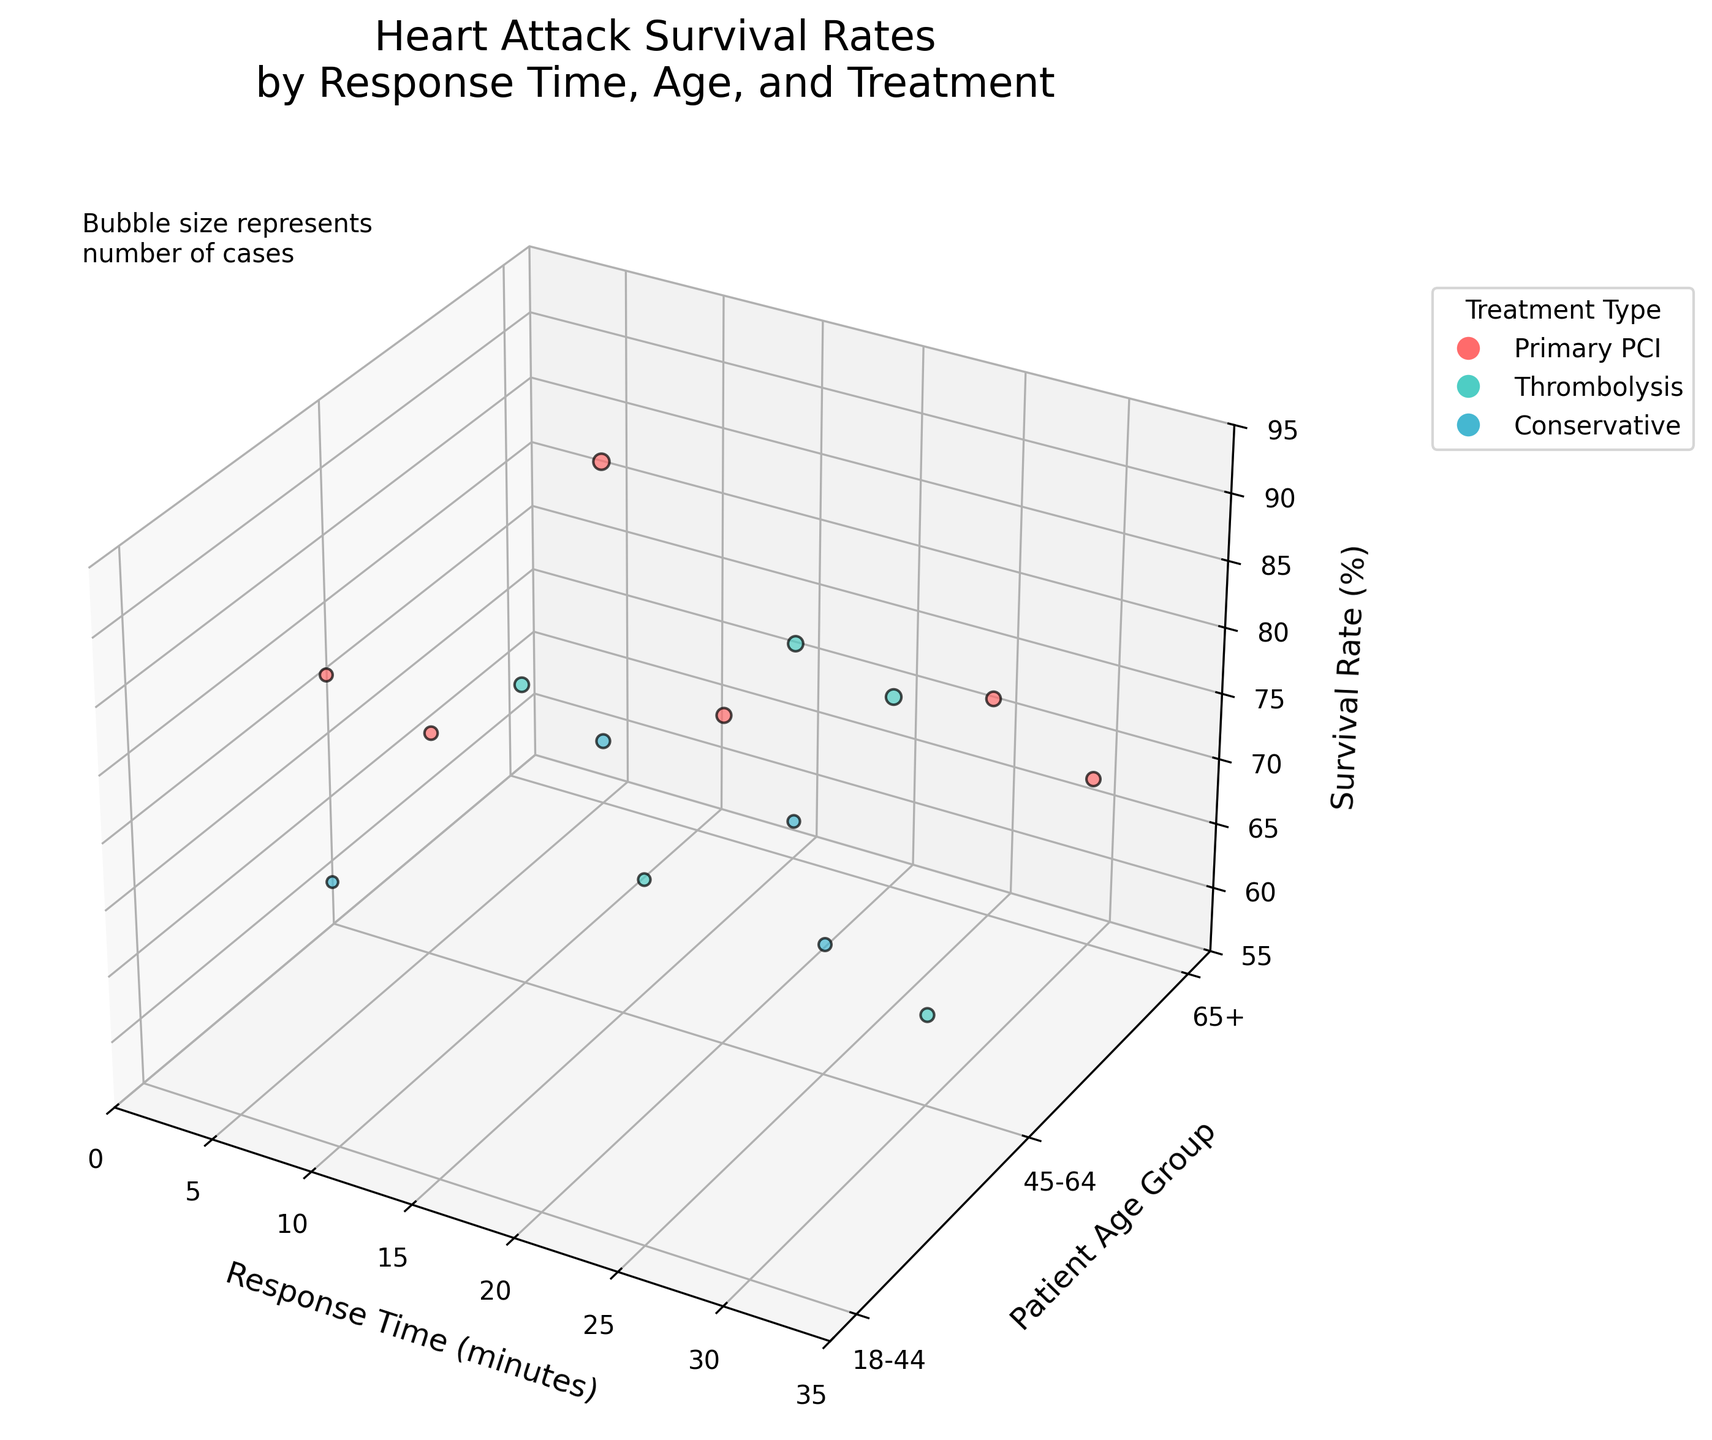What is the title of the figure? The title of the figure is displayed at the top and it reads "Heart Attack Survival Rates by Response Time, Age, and Treatment".
Answer: Heart Attack Survival Rates by Response Time, Age, and Treatment What kind of treatment is represented by the red color? The color legend on the right side of the figure uses red to denote Primary PCI treatment type.
Answer: Primary PCI Which age group is denoted by the y-axis label '0'? According to the y-axis labels, '0' corresponds to the age group '18-44'.
Answer: 18-44 How many bubbles in total represent the Conservative treatment? Bubbles are colored according to treatment types. By counting the blue-colored bubbles, there are three representing the Conservative treatment.
Answer: 3 Which combination of treatment type and age group has the highest survival rate? By looking at the z-axis (Survival Rate) and corresponding bubbles, the highest survival rate is achieved by Primary PCI treatment for the 18-44 age group.
Answer: Primary PCI, 18-44 What is the size representation for the largest bubble? The size of the bubbles represents the number of cases, and the largest bubble corresponds to 1200 cases as noted in the data file.
Answer: 1200 cases How does the survival rate change with increasing response time for patients aged 65+ treated with Primary PCI? For patients aged 65+ treated with Primary PCI, as the response time increases from 5 to 30 minutes, the survival rate drops from 82% to 68%.
Answer: Decreases from 82% to 68% Which age group and treatment type combination has the lowest survival rate and what is that rate? By examining the lowest point on the z-axis, the combination of Conservative treatment for the 65+ age group has the lowest survival rate of 58%.
Answer: Conservative, 65+, 58% Compare the survival rates between Primary PCI and Thrombolysis treatments for the 45-64 age group at a response time of 10 minutes. By checking the relevant bubbles: Primary PCI has a survival rate of 80%, whereas Thrombolysis has a survival rate of 62% at the same response time for the 45-64 age group.
Answer: Primary PCI: 80%, Thrombolysis: 62% What trends can be observed in the survival rates for the Thrombolysis treatment across different age groups as the response time increases from 10 to 25 minutes? Reviewing the Thrombolysis treatment bubbles, survival rate for 18-44 age group increases slightly from 78% to 82%, for 45-64 age group decreases significantly from 78% to 62%, and for 65+ age group has less variability with rates around 70-72%.
Answer: 18-44: slight increase, 45-64: significant decrease, 65+: less varied 